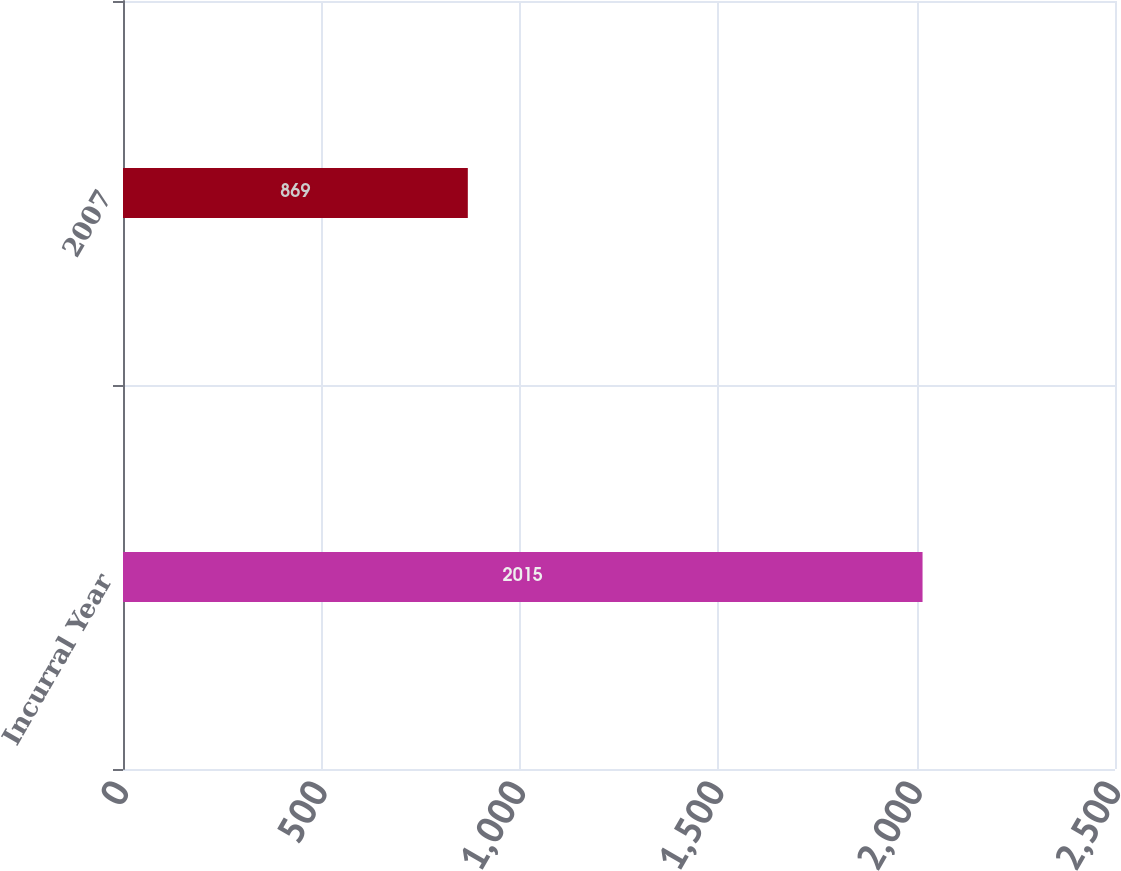<chart> <loc_0><loc_0><loc_500><loc_500><bar_chart><fcel>Incurral Year<fcel>2007<nl><fcel>2015<fcel>869<nl></chart> 